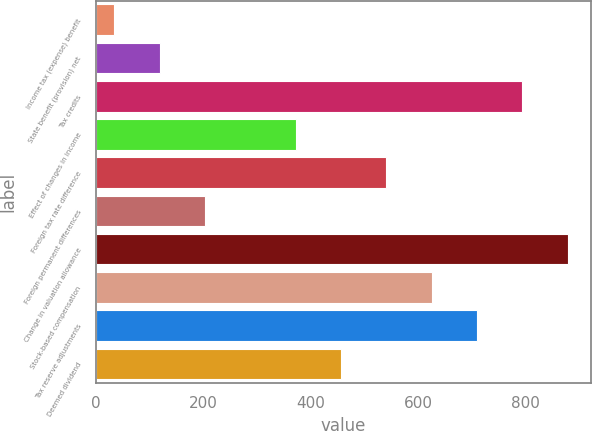Convert chart to OTSL. <chart><loc_0><loc_0><loc_500><loc_500><bar_chart><fcel>Income tax (expense) benefit<fcel>State benefit (provision) net<fcel>Tax credits<fcel>Effect of changes in income<fcel>Foreign tax rate difference<fcel>Foreign permanent differences<fcel>Change in valuation allowance<fcel>Stock-based compensation<fcel>Tax reserve adjustments<fcel>Deemed dividend<nl><fcel>35<fcel>119.28<fcel>793.52<fcel>372.12<fcel>540.68<fcel>203.56<fcel>877.84<fcel>624.96<fcel>709.24<fcel>456.4<nl></chart> 